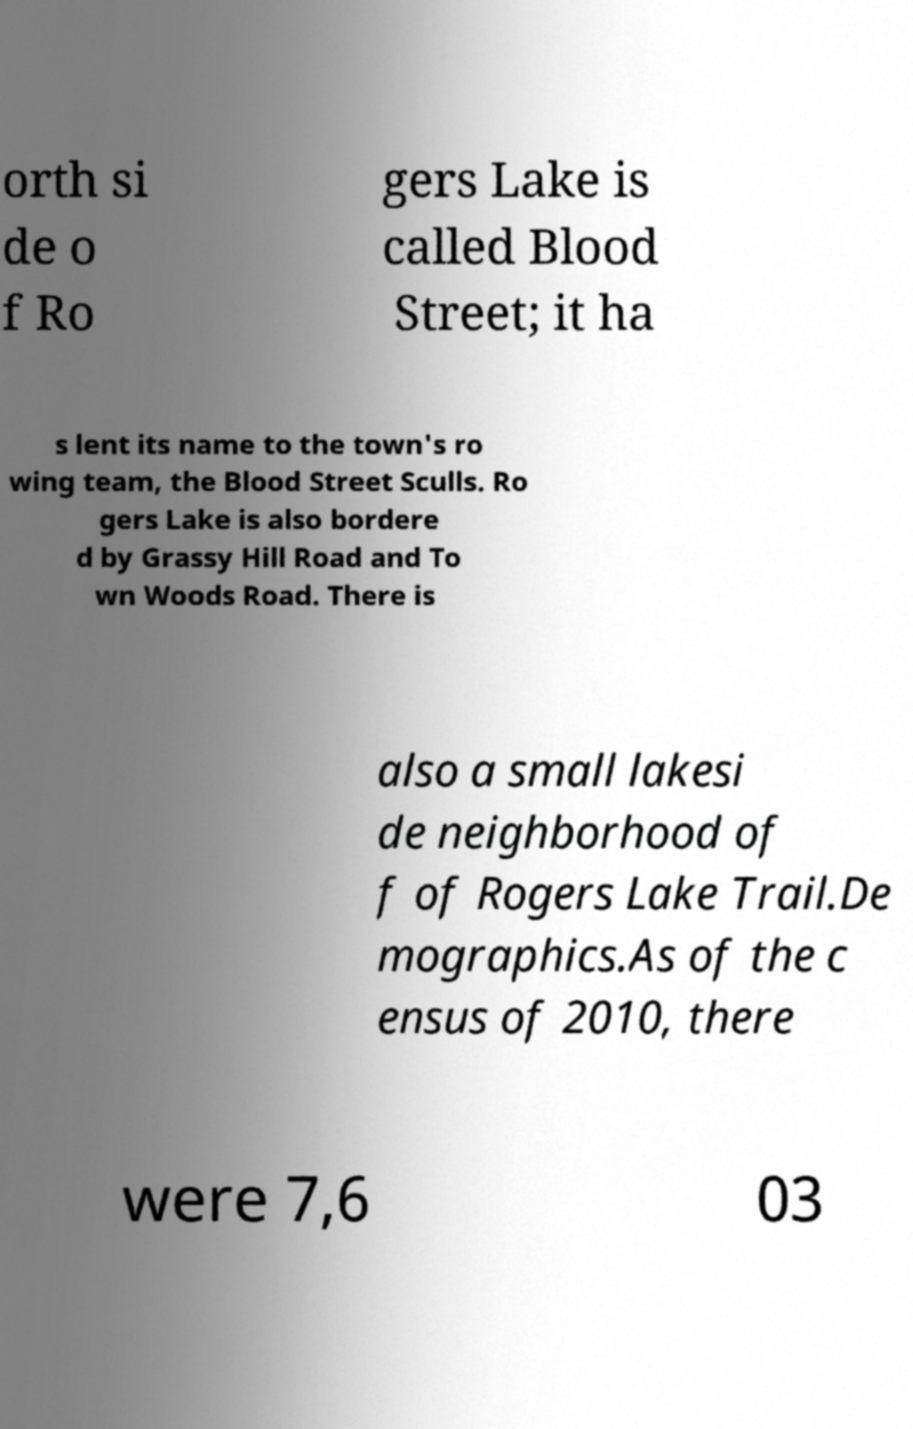Could you assist in decoding the text presented in this image and type it out clearly? orth si de o f Ro gers Lake is called Blood Street; it ha s lent its name to the town's ro wing team, the Blood Street Sculls. Ro gers Lake is also bordere d by Grassy Hill Road and To wn Woods Road. There is also a small lakesi de neighborhood of f of Rogers Lake Trail.De mographics.As of the c ensus of 2010, there were 7,6 03 